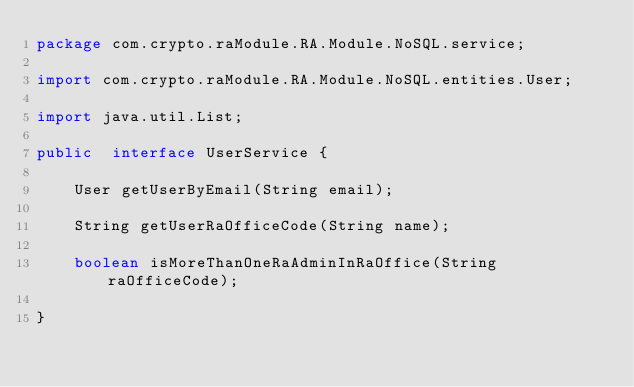<code> <loc_0><loc_0><loc_500><loc_500><_Java_>package com.crypto.raModule.RA.Module.NoSQL.service;

import com.crypto.raModule.RA.Module.NoSQL.entities.User;

import java.util.List;

public  interface UserService {

    User getUserByEmail(String email);

    String getUserRaOfficeCode(String name);

    boolean isMoreThanOneRaAdminInRaOffice(String raOfficeCode);

}
</code> 